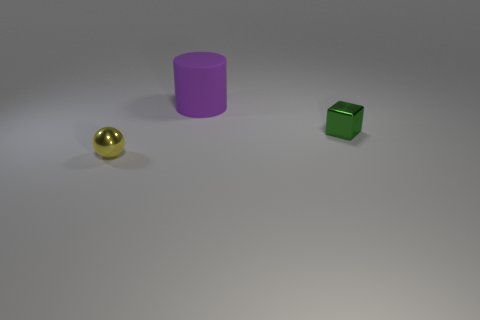Is there anything else that is the same material as the purple cylinder?
Ensure brevity in your answer.  No. Is there any other thing that has the same size as the rubber cylinder?
Ensure brevity in your answer.  No. The green shiny object that is to the right of the tiny yellow thing has what shape?
Offer a very short reply. Cube. What number of tiny objects have the same material as the cube?
Ensure brevity in your answer.  1. There is a tiny green metallic object; is its shape the same as the shiny thing that is to the left of the tiny block?
Make the answer very short. No. There is a tiny metal thing that is to the right of the object that is behind the small green cube; is there a green object right of it?
Give a very brief answer. No. There is a thing that is left of the large purple rubber cylinder; how big is it?
Keep it short and to the point. Small. There is a thing that is the same size as the metallic ball; what material is it?
Offer a terse response. Metal. Does the tiny green metal object have the same shape as the large purple matte object?
Provide a short and direct response. No. What number of things are either small green shiny blocks or metal things on the left side of the purple cylinder?
Keep it short and to the point. 2. 